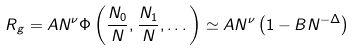Convert formula to latex. <formula><loc_0><loc_0><loc_500><loc_500>R _ { g } = A N ^ { \nu } \Phi \left ( \frac { N _ { 0 } } { N } , \frac { N _ { 1 } } { N } , \dots \right ) \simeq A N ^ { \nu } \left ( 1 - B N ^ { - \Delta } \right )</formula> 